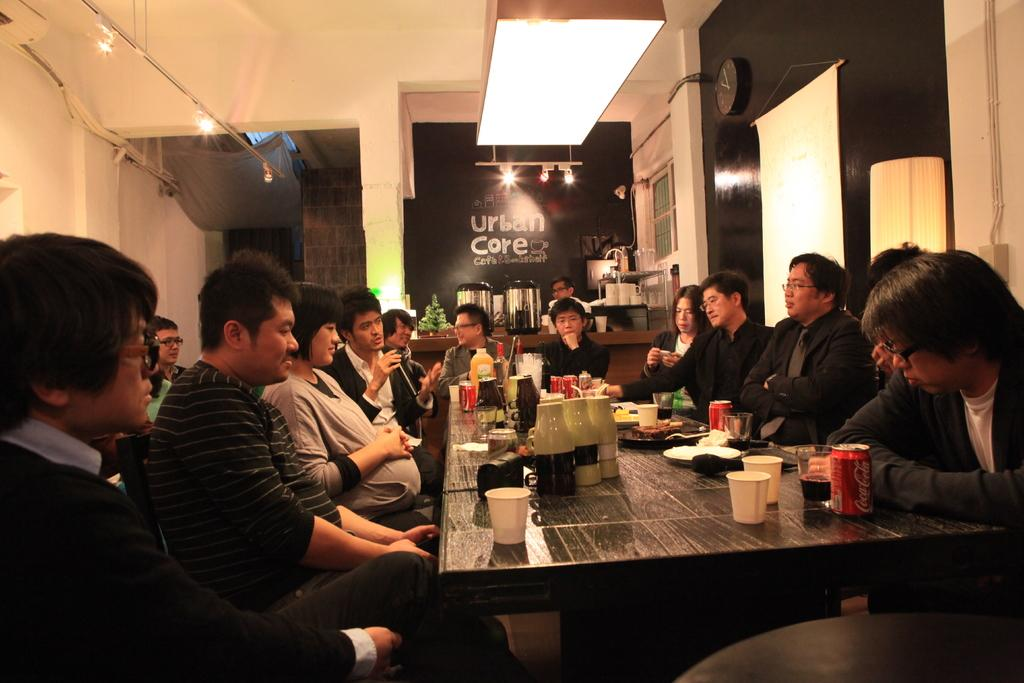<image>
Provide a brief description of the given image. Many people eating at the Urban Care restaurant 